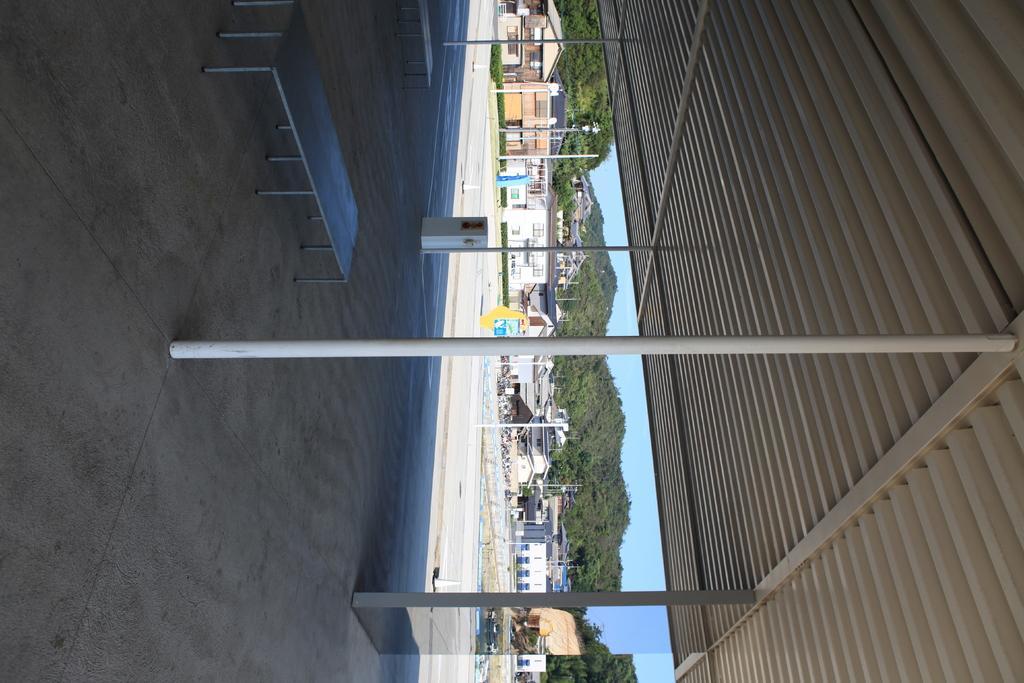Could you give a brief overview of what you see in this image? There is a shed on the right side of the image and there is a pole and bench in the center. There are houses, poles, it seems like mountains and sky in the background area. 